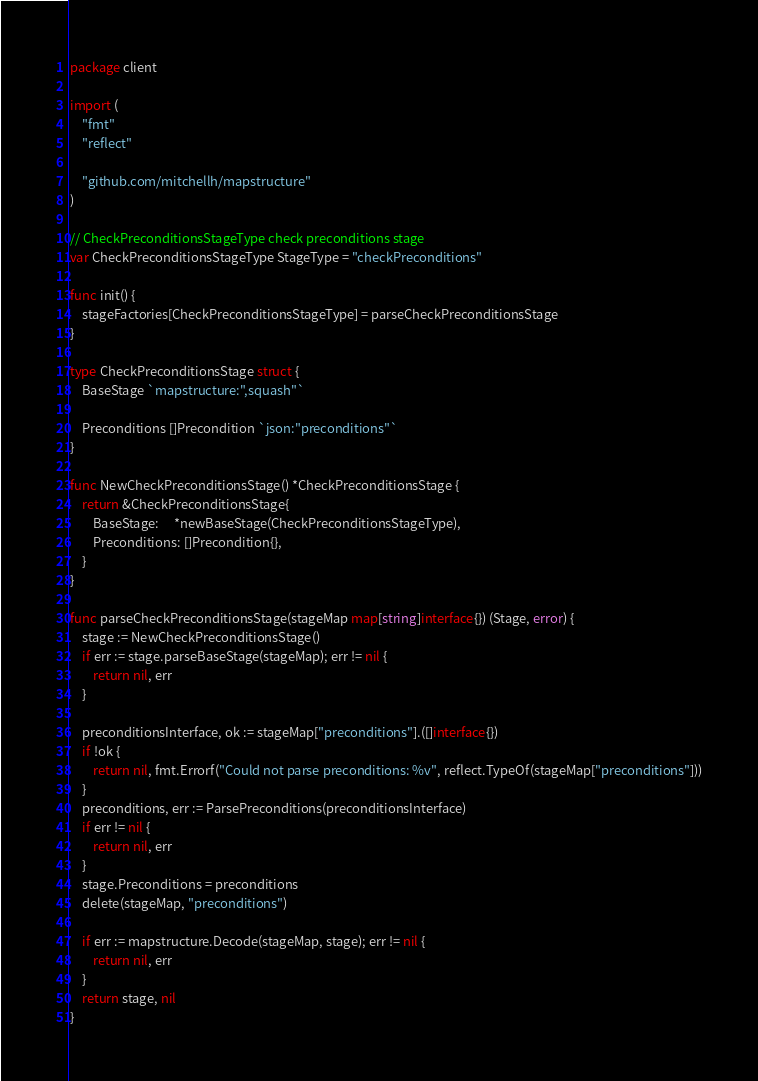Convert code to text. <code><loc_0><loc_0><loc_500><loc_500><_Go_>package client

import (
	"fmt"
	"reflect"

	"github.com/mitchellh/mapstructure"
)

// CheckPreconditionsStageType check preconditions stage
var CheckPreconditionsStageType StageType = "checkPreconditions"

func init() {
	stageFactories[CheckPreconditionsStageType] = parseCheckPreconditionsStage
}

type CheckPreconditionsStage struct {
	BaseStage `mapstructure:",squash"`

	Preconditions []Precondition `json:"preconditions"`
}

func NewCheckPreconditionsStage() *CheckPreconditionsStage {
	return &CheckPreconditionsStage{
		BaseStage:     *newBaseStage(CheckPreconditionsStageType),
		Preconditions: []Precondition{},
	}
}

func parseCheckPreconditionsStage(stageMap map[string]interface{}) (Stage, error) {
	stage := NewCheckPreconditionsStage()
	if err := stage.parseBaseStage(stageMap); err != nil {
		return nil, err
	}

	preconditionsInterface, ok := stageMap["preconditions"].([]interface{})
	if !ok {
		return nil, fmt.Errorf("Could not parse preconditions: %v", reflect.TypeOf(stageMap["preconditions"]))
	}
	preconditions, err := ParsePreconditions(preconditionsInterface)
	if err != nil {
		return nil, err
	}
	stage.Preconditions = preconditions
	delete(stageMap, "preconditions")

	if err := mapstructure.Decode(stageMap, stage); err != nil {
		return nil, err
	}
	return stage, nil
}
</code> 